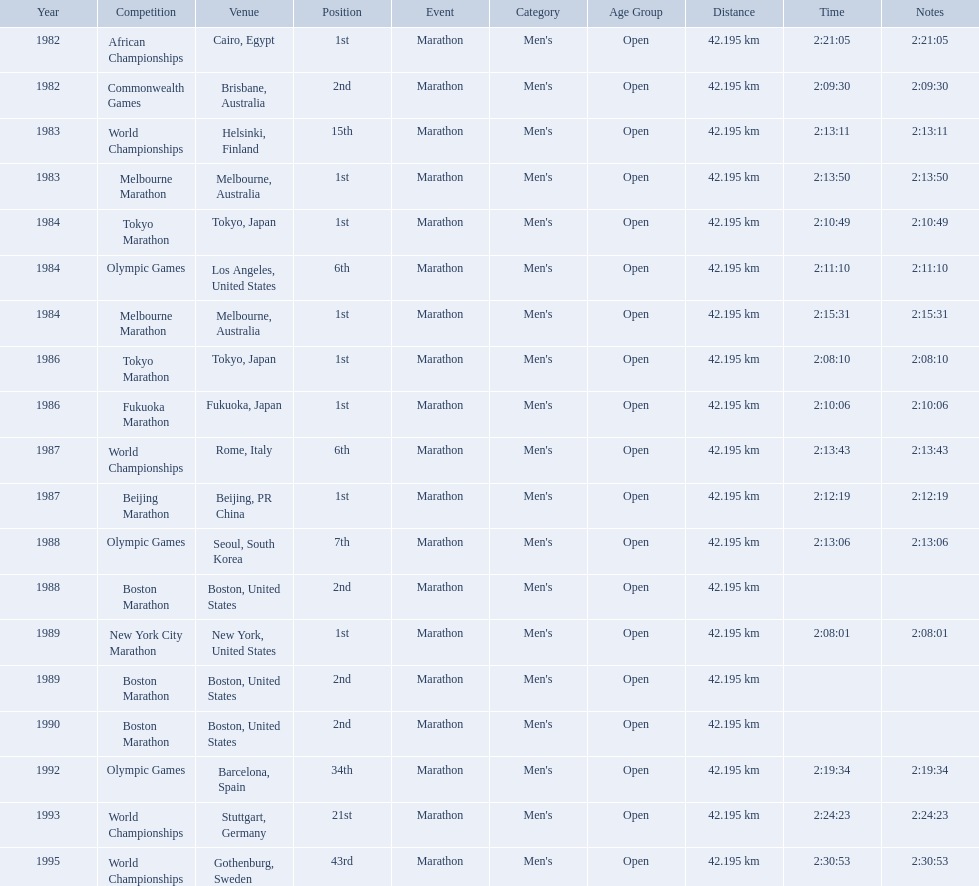What are all the competitions? African Championships, Commonwealth Games, World Championships, Melbourne Marathon, Tokyo Marathon, Olympic Games, Melbourne Marathon, Tokyo Marathon, Fukuoka Marathon, World Championships, Beijing Marathon, Olympic Games, Boston Marathon, New York City Marathon, Boston Marathon, Boston Marathon, Olympic Games, World Championships, World Championships. Can you parse all the data within this table? {'header': ['Year', 'Competition', 'Venue', 'Position', 'Event', 'Category', 'Age Group', 'Distance', 'Time', 'Notes'], 'rows': [['1982', 'African Championships', 'Cairo, Egypt', '1st', 'Marathon', "Men's", 'Open', '42.195 km', '2:21:05', '2:21:05'], ['1982', 'Commonwealth Games', 'Brisbane, Australia', '2nd', 'Marathon', "Men's", 'Open', '42.195 km', '2:09:30', '2:09:30'], ['1983', 'World Championships', 'Helsinki, Finland', '15th', 'Marathon', "Men's", 'Open', '42.195 km', '2:13:11', '2:13:11'], ['1983', 'Melbourne Marathon', 'Melbourne, Australia', '1st', 'Marathon', "Men's", 'Open', '42.195 km', '2:13:50', '2:13:50'], ['1984', 'Tokyo Marathon', 'Tokyo, Japan', '1st', 'Marathon', "Men's", 'Open', '42.195 km', '2:10:49', '2:10:49'], ['1984', 'Olympic Games', 'Los Angeles, United States', '6th', 'Marathon', "Men's", 'Open', '42.195 km', '2:11:10', '2:11:10'], ['1984', 'Melbourne Marathon', 'Melbourne, Australia', '1st', 'Marathon', "Men's", 'Open', '42.195 km', '2:15:31', '2:15:31'], ['1986', 'Tokyo Marathon', 'Tokyo, Japan', '1st', 'Marathon', "Men's", 'Open', '42.195 km', '2:08:10', '2:08:10'], ['1986', 'Fukuoka Marathon', 'Fukuoka, Japan', '1st', 'Marathon', "Men's", 'Open', '42.195 km', '2:10:06', '2:10:06'], ['1987', 'World Championships', 'Rome, Italy', '6th', 'Marathon', "Men's", 'Open', '42.195 km', '2:13:43', '2:13:43'], ['1987', 'Beijing Marathon', 'Beijing, PR China', '1st', 'Marathon', "Men's", 'Open', '42.195 km', '2:12:19', '2:12:19'], ['1988', 'Olympic Games', 'Seoul, South Korea', '7th', 'Marathon', "Men's", 'Open', '42.195 km', '2:13:06', '2:13:06'], ['1988', 'Boston Marathon', 'Boston, United States', '2nd', 'Marathon', "Men's", 'Open', '42.195 km', '', ''], ['1989', 'New York City Marathon', 'New York, United States', '1st', 'Marathon', "Men's", 'Open', '42.195 km', '2:08:01', '2:08:01'], ['1989', 'Boston Marathon', 'Boston, United States', '2nd', 'Marathon', "Men's", 'Open', '42.195 km', '', ''], ['1990', 'Boston Marathon', 'Boston, United States', '2nd', 'Marathon', "Men's", 'Open', '42.195 km', '', ''], ['1992', 'Olympic Games', 'Barcelona, Spain', '34th', 'Marathon', "Men's", 'Open', '42.195 km', '2:19:34', '2:19:34'], ['1993', 'World Championships', 'Stuttgart, Germany', '21st', 'Marathon', "Men's", 'Open', '42.195 km', '2:24:23', '2:24:23'], ['1995', 'World Championships', 'Gothenburg, Sweden', '43rd', 'Marathon', "Men's", 'Open', '42.195 km', '2:30:53', '2:30:53']]} Where were they located? Cairo, Egypt, Brisbane, Australia, Helsinki, Finland, Melbourne, Australia, Tokyo, Japan, Los Angeles, United States, Melbourne, Australia, Tokyo, Japan, Fukuoka, Japan, Rome, Italy, Beijing, PR China, Seoul, South Korea, Boston, United States, New York, United States, Boston, United States, Boston, United States, Barcelona, Spain, Stuttgart, Germany, Gothenburg, Sweden. And which competition was in china? Beijing Marathon. What are the competitions? African Championships, Cairo, Egypt, Commonwealth Games, Brisbane, Australia, World Championships, Helsinki, Finland, Melbourne Marathon, Melbourne, Australia, Tokyo Marathon, Tokyo, Japan, Olympic Games, Los Angeles, United States, Melbourne Marathon, Melbourne, Australia, Tokyo Marathon, Tokyo, Japan, Fukuoka Marathon, Fukuoka, Japan, World Championships, Rome, Italy, Beijing Marathon, Beijing, PR China, Olympic Games, Seoul, South Korea, Boston Marathon, Boston, United States, New York City Marathon, New York, United States, Boston Marathon, Boston, United States, Boston Marathon, Boston, United States, Olympic Games, Barcelona, Spain, World Championships, Stuttgart, Germany, World Championships, Gothenburg, Sweden. Which ones occured in china? Beijing Marathon, Beijing, PR China. Which one is it? Beijing Marathon. 